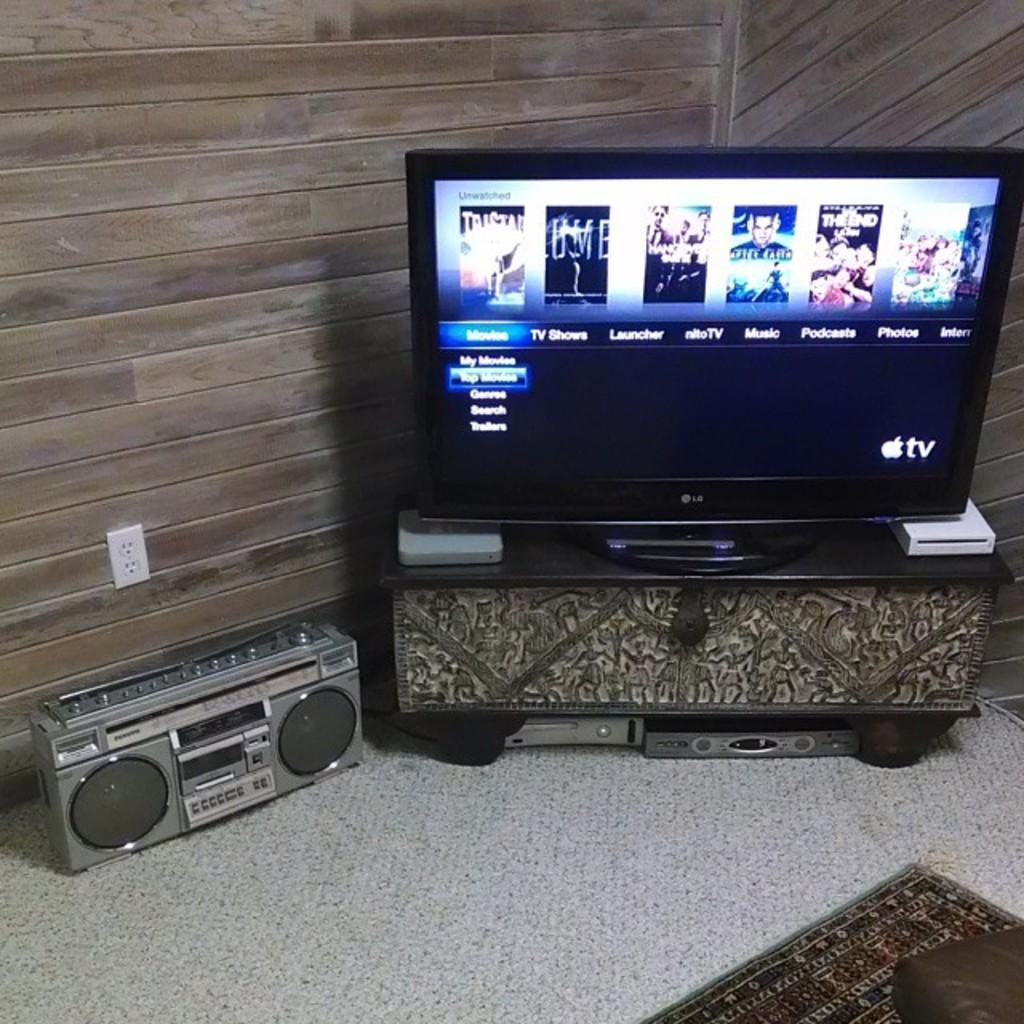<image>
Present a compact description of the photo's key features. A black LG tv displaying the menu of options including movies and tv shows. 